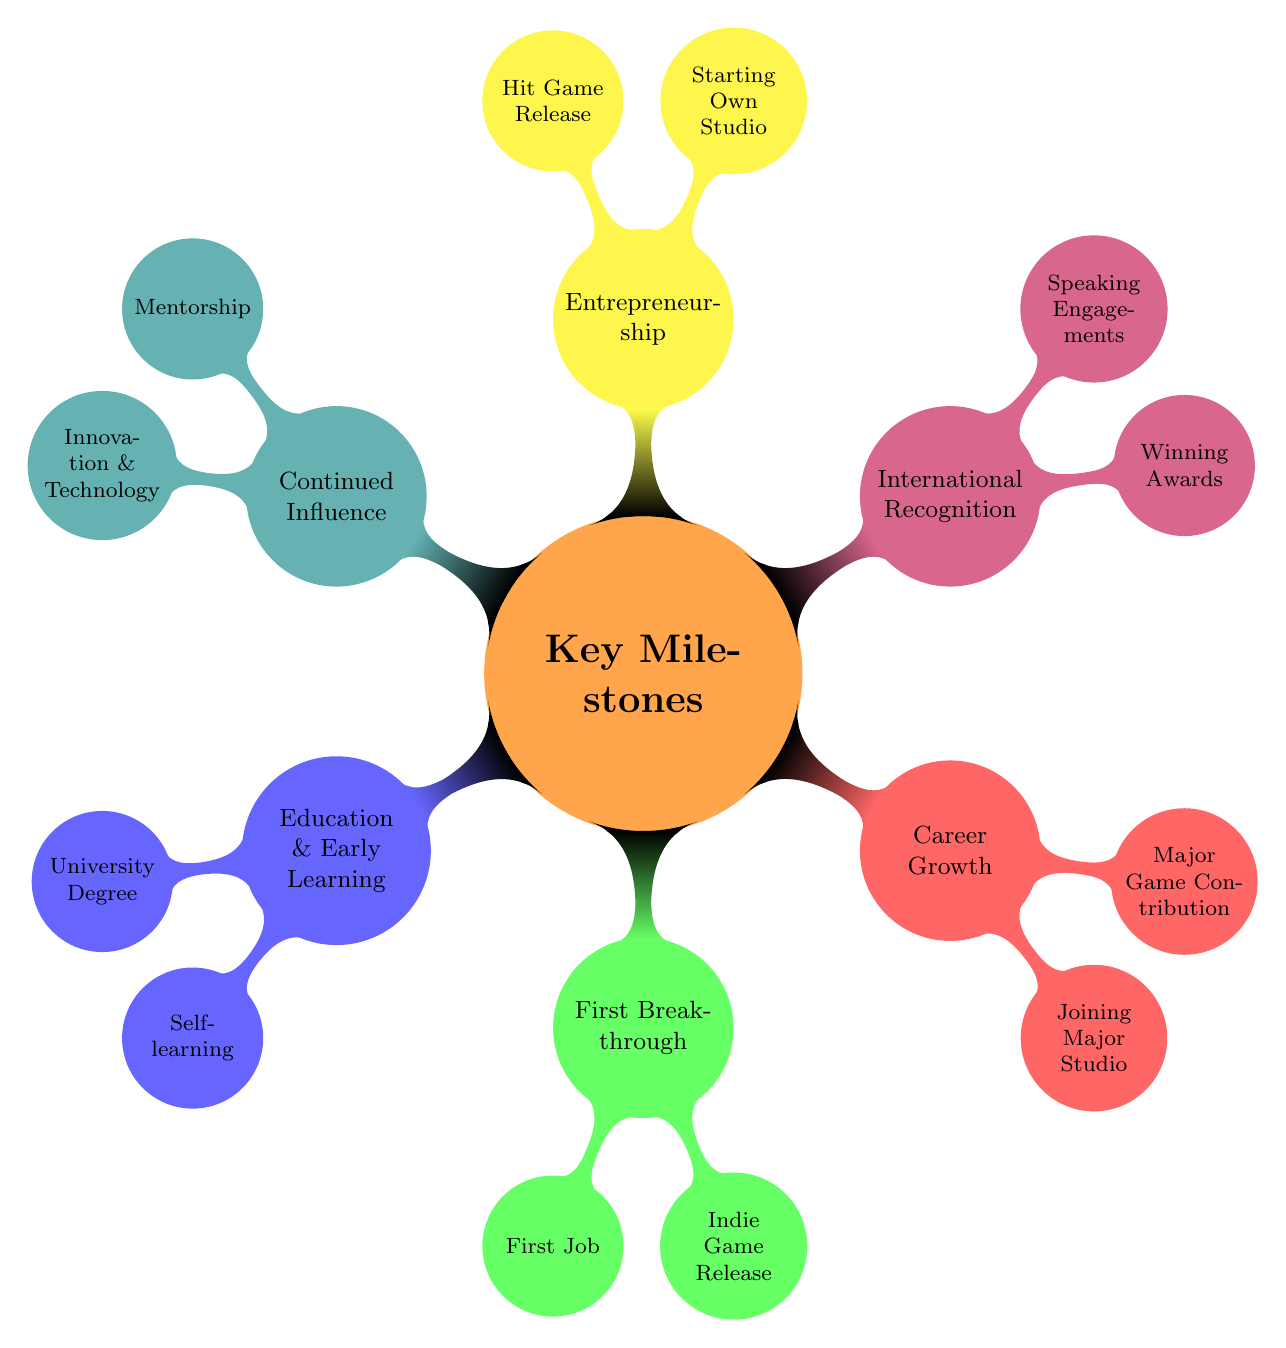What are the two categories listed under Education and Early Learning? The node "Education and Early Learning" has two child nodes: "University Degree" and "Self-learning". These are parts of the main category indicating the foundational learning paths in game development.
Answer: University Degree, Self-learning How many key milestones are listed in the diagram? There are 6 main categories represented in the diagram: Education & Early Learning, First Breakthrough, Career Growth, International Recognition, Entrepreneurship, and Continued Influence. Therefore, the total number is 6.
Answer: 6 What position did the individual hold at Krome Studios? The child node under "First Breakthrough" for "First Job in the Industry" states that the individual worked as a "Junior Developer" at Krome Studios. This answers the question about their initial position.
Answer: Junior Developer What was significant about the game 'Surf Down Under'? Under "Entrepreneurship", the node "Hit Game Release" specifies that 'Surf Down Under' achieved over 5 million downloads, marking it as a significant success in the developer's career. This highlights the accomplishment of reaching a wide audience and commercial success.
Answer: Over 5 million downloads What role did the individual take on at Ubisoft? The "Joining a Major Studio" node under "Career Growth" indicates that the individual moved to Ubisoft’s Sydney Office, which implies they took on a significant role at a major gaming company, though the specific title isn't given in this node.
Answer: Moved to Ubisoft’s Sydney Office Which award did the individual win, and what was it for? The "Winning Awards" node under "International Recognition" states that the individual received the ‘Best Game Design’ award. This cleverly links their recognition to a specific achievement in game design, contributing to their profile as a successful developer.
Answer: Best Game Design What unique contribution is mentioned under Continued Influence? The "Innovation and Technology" child node indicates that the individual was involved in pioneering VR experiences with “Australian Wilderness VR”, showcasing their influence on newer gaming technologies and trends.
Answer: Pioneering VR experiences What year is implied by the term “First Indie Game Release”? Since “First Indie Game Release” is a milestone that typically follows initial learning and entry into the industry, it directly correlates to the early stage in a career. However, the specific year is not provided in the diagram—it assumes a timeline from the beginning of one's career.
Answer: Not provided 